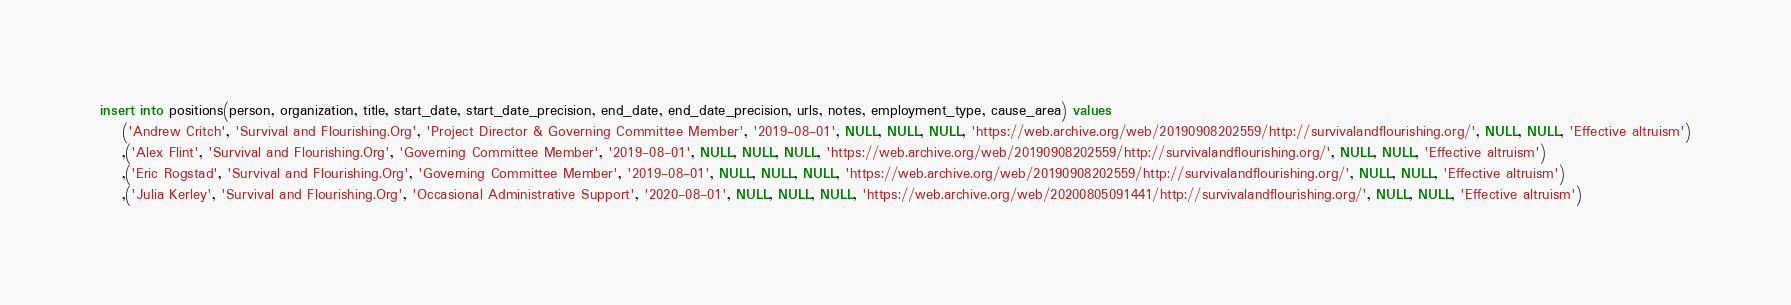<code> <loc_0><loc_0><loc_500><loc_500><_SQL_>insert into positions(person, organization, title, start_date, start_date_precision, end_date, end_date_precision, urls, notes, employment_type, cause_area) values
	('Andrew Critch', 'Survival and Flourishing.Org', 'Project Director & Governing Committee Member', '2019-08-01', NULL, NULL, NULL, 'https://web.archive.org/web/20190908202559/http://survivalandflourishing.org/', NULL, NULL, 'Effective altruism')
	,('Alex Flint', 'Survival and Flourishing.Org', 'Governing Committee Member', '2019-08-01', NULL, NULL, NULL, 'https://web.archive.org/web/20190908202559/http://survivalandflourishing.org/', NULL, NULL, 'Effective altruism')  
	,('Eric Rogstad', 'Survival and Flourishing.Org', 'Governing Committee Member', '2019-08-01', NULL, NULL, NULL, 'https://web.archive.org/web/20190908202559/http://survivalandflourishing.org/', NULL, NULL, 'Effective altruism')  
	,('Julia Kerley', 'Survival and Flourishing.Org', 'Occasional Administrative Support', '2020-08-01', NULL, NULL, NULL, 'https://web.archive.org/web/20200805091441/http://survivalandflourishing.org/', NULL, NULL, 'Effective altruism')    </code> 